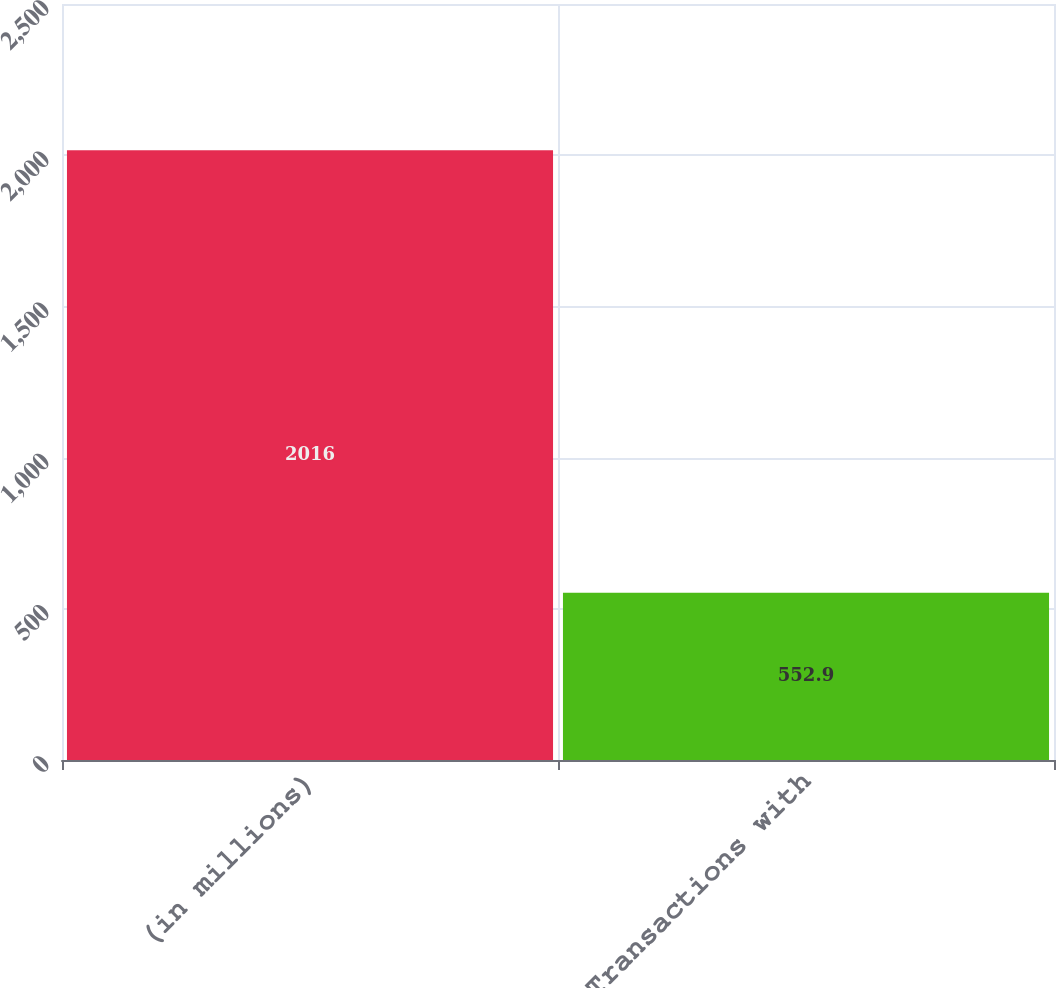Convert chart to OTSL. <chart><loc_0><loc_0><loc_500><loc_500><bar_chart><fcel>(in millions)<fcel>Transactions with<nl><fcel>2016<fcel>552.9<nl></chart> 